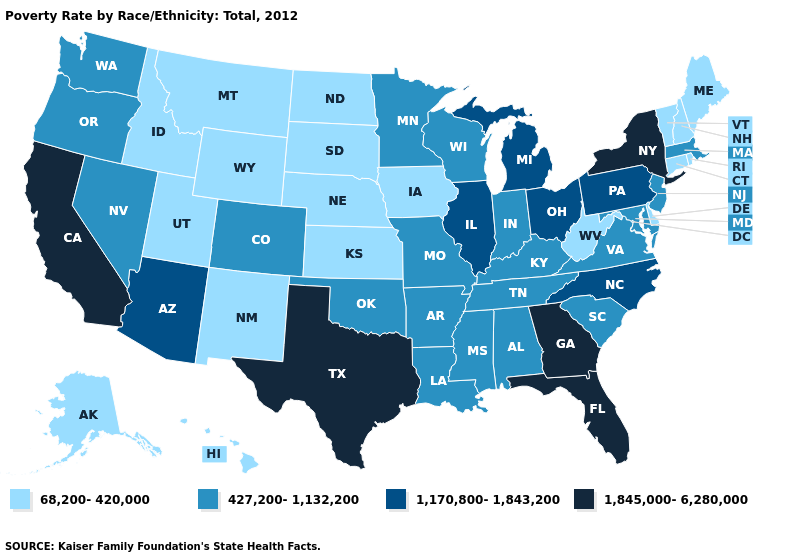Does the map have missing data?
Answer briefly. No. Among the states that border Michigan , does Ohio have the highest value?
Short answer required. Yes. Name the states that have a value in the range 68,200-420,000?
Short answer required. Alaska, Connecticut, Delaware, Hawaii, Idaho, Iowa, Kansas, Maine, Montana, Nebraska, New Hampshire, New Mexico, North Dakota, Rhode Island, South Dakota, Utah, Vermont, West Virginia, Wyoming. Which states hav the highest value in the MidWest?
Give a very brief answer. Illinois, Michigan, Ohio. Which states have the highest value in the USA?
Answer briefly. California, Florida, Georgia, New York, Texas. What is the lowest value in the USA?
Answer briefly. 68,200-420,000. Name the states that have a value in the range 427,200-1,132,200?
Write a very short answer. Alabama, Arkansas, Colorado, Indiana, Kentucky, Louisiana, Maryland, Massachusetts, Minnesota, Mississippi, Missouri, Nevada, New Jersey, Oklahoma, Oregon, South Carolina, Tennessee, Virginia, Washington, Wisconsin. Name the states that have a value in the range 427,200-1,132,200?
Be succinct. Alabama, Arkansas, Colorado, Indiana, Kentucky, Louisiana, Maryland, Massachusetts, Minnesota, Mississippi, Missouri, Nevada, New Jersey, Oklahoma, Oregon, South Carolina, Tennessee, Virginia, Washington, Wisconsin. Name the states that have a value in the range 1,845,000-6,280,000?
Quick response, please. California, Florida, Georgia, New York, Texas. Name the states that have a value in the range 68,200-420,000?
Short answer required. Alaska, Connecticut, Delaware, Hawaii, Idaho, Iowa, Kansas, Maine, Montana, Nebraska, New Hampshire, New Mexico, North Dakota, Rhode Island, South Dakota, Utah, Vermont, West Virginia, Wyoming. What is the highest value in the Northeast ?
Be succinct. 1,845,000-6,280,000. Does California have the highest value in the West?
Keep it brief. Yes. Does the first symbol in the legend represent the smallest category?
Give a very brief answer. Yes. Does California have the highest value in the West?
Be succinct. Yes. 